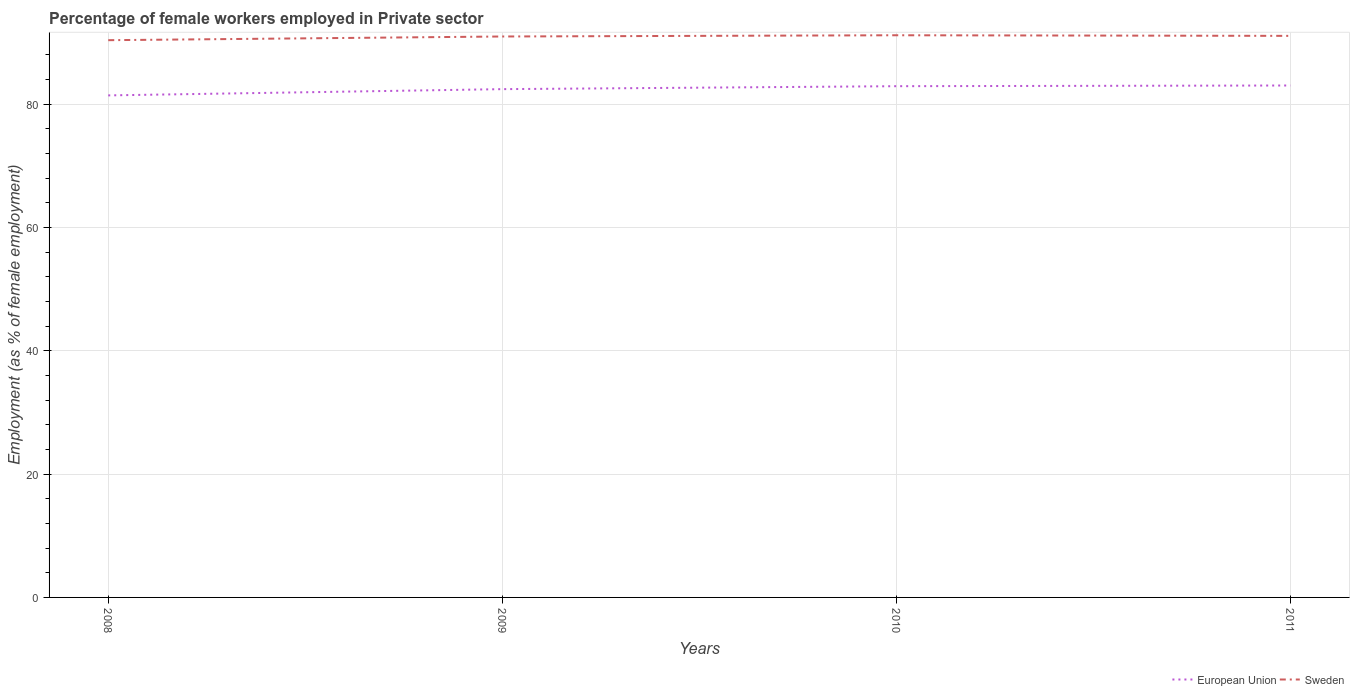How many different coloured lines are there?
Your response must be concise. 2. Does the line corresponding to Sweden intersect with the line corresponding to European Union?
Provide a succinct answer. No. Across all years, what is the maximum percentage of females employed in Private sector in Sweden?
Your response must be concise. 90.4. What is the total percentage of females employed in Private sector in Sweden in the graph?
Offer a very short reply. -0.6. What is the difference between the highest and the second highest percentage of females employed in Private sector in European Union?
Your answer should be very brief. 1.61. Is the percentage of females employed in Private sector in European Union strictly greater than the percentage of females employed in Private sector in Sweden over the years?
Provide a succinct answer. Yes. How many lines are there?
Make the answer very short. 2. How many years are there in the graph?
Provide a succinct answer. 4. Are the values on the major ticks of Y-axis written in scientific E-notation?
Provide a succinct answer. No. Does the graph contain grids?
Make the answer very short. Yes. What is the title of the graph?
Your answer should be very brief. Percentage of female workers employed in Private sector. Does "Belarus" appear as one of the legend labels in the graph?
Your answer should be very brief. No. What is the label or title of the X-axis?
Your answer should be compact. Years. What is the label or title of the Y-axis?
Provide a succinct answer. Employment (as % of female employment). What is the Employment (as % of female employment) of European Union in 2008?
Make the answer very short. 81.44. What is the Employment (as % of female employment) in Sweden in 2008?
Provide a short and direct response. 90.4. What is the Employment (as % of female employment) in European Union in 2009?
Keep it short and to the point. 82.46. What is the Employment (as % of female employment) of Sweden in 2009?
Your answer should be compact. 91. What is the Employment (as % of female employment) of European Union in 2010?
Offer a terse response. 82.94. What is the Employment (as % of female employment) in Sweden in 2010?
Make the answer very short. 91.2. What is the Employment (as % of female employment) in European Union in 2011?
Provide a short and direct response. 83.05. What is the Employment (as % of female employment) in Sweden in 2011?
Your answer should be compact. 91.1. Across all years, what is the maximum Employment (as % of female employment) of European Union?
Your answer should be very brief. 83.05. Across all years, what is the maximum Employment (as % of female employment) in Sweden?
Keep it short and to the point. 91.2. Across all years, what is the minimum Employment (as % of female employment) in European Union?
Provide a short and direct response. 81.44. Across all years, what is the minimum Employment (as % of female employment) in Sweden?
Your response must be concise. 90.4. What is the total Employment (as % of female employment) in European Union in the graph?
Ensure brevity in your answer.  329.89. What is the total Employment (as % of female employment) in Sweden in the graph?
Your answer should be very brief. 363.7. What is the difference between the Employment (as % of female employment) in European Union in 2008 and that in 2009?
Offer a very short reply. -1.01. What is the difference between the Employment (as % of female employment) in Sweden in 2008 and that in 2009?
Provide a short and direct response. -0.6. What is the difference between the Employment (as % of female employment) of European Union in 2008 and that in 2010?
Offer a terse response. -1.49. What is the difference between the Employment (as % of female employment) in Sweden in 2008 and that in 2010?
Provide a succinct answer. -0.8. What is the difference between the Employment (as % of female employment) of European Union in 2008 and that in 2011?
Ensure brevity in your answer.  -1.61. What is the difference between the Employment (as % of female employment) of Sweden in 2008 and that in 2011?
Give a very brief answer. -0.7. What is the difference between the Employment (as % of female employment) in European Union in 2009 and that in 2010?
Make the answer very short. -0.48. What is the difference between the Employment (as % of female employment) in Sweden in 2009 and that in 2010?
Offer a terse response. -0.2. What is the difference between the Employment (as % of female employment) in European Union in 2009 and that in 2011?
Ensure brevity in your answer.  -0.59. What is the difference between the Employment (as % of female employment) of European Union in 2010 and that in 2011?
Give a very brief answer. -0.11. What is the difference between the Employment (as % of female employment) in Sweden in 2010 and that in 2011?
Keep it short and to the point. 0.1. What is the difference between the Employment (as % of female employment) in European Union in 2008 and the Employment (as % of female employment) in Sweden in 2009?
Offer a very short reply. -9.56. What is the difference between the Employment (as % of female employment) of European Union in 2008 and the Employment (as % of female employment) of Sweden in 2010?
Give a very brief answer. -9.76. What is the difference between the Employment (as % of female employment) in European Union in 2008 and the Employment (as % of female employment) in Sweden in 2011?
Provide a succinct answer. -9.66. What is the difference between the Employment (as % of female employment) in European Union in 2009 and the Employment (as % of female employment) in Sweden in 2010?
Your answer should be compact. -8.74. What is the difference between the Employment (as % of female employment) of European Union in 2009 and the Employment (as % of female employment) of Sweden in 2011?
Provide a succinct answer. -8.64. What is the difference between the Employment (as % of female employment) in European Union in 2010 and the Employment (as % of female employment) in Sweden in 2011?
Provide a short and direct response. -8.16. What is the average Employment (as % of female employment) in European Union per year?
Ensure brevity in your answer.  82.47. What is the average Employment (as % of female employment) in Sweden per year?
Offer a very short reply. 90.92. In the year 2008, what is the difference between the Employment (as % of female employment) in European Union and Employment (as % of female employment) in Sweden?
Your answer should be compact. -8.96. In the year 2009, what is the difference between the Employment (as % of female employment) in European Union and Employment (as % of female employment) in Sweden?
Provide a short and direct response. -8.54. In the year 2010, what is the difference between the Employment (as % of female employment) in European Union and Employment (as % of female employment) in Sweden?
Provide a short and direct response. -8.26. In the year 2011, what is the difference between the Employment (as % of female employment) in European Union and Employment (as % of female employment) in Sweden?
Give a very brief answer. -8.05. What is the ratio of the Employment (as % of female employment) in Sweden in 2008 to that in 2010?
Ensure brevity in your answer.  0.99. What is the ratio of the Employment (as % of female employment) in European Union in 2008 to that in 2011?
Ensure brevity in your answer.  0.98. What is the ratio of the Employment (as % of female employment) of European Union in 2009 to that in 2010?
Ensure brevity in your answer.  0.99. What is the ratio of the Employment (as % of female employment) in Sweden in 2009 to that in 2010?
Your answer should be compact. 1. What is the ratio of the Employment (as % of female employment) in European Union in 2009 to that in 2011?
Offer a very short reply. 0.99. What is the ratio of the Employment (as % of female employment) in European Union in 2010 to that in 2011?
Offer a terse response. 1. What is the difference between the highest and the second highest Employment (as % of female employment) of European Union?
Your answer should be compact. 0.11. What is the difference between the highest and the lowest Employment (as % of female employment) of European Union?
Your answer should be very brief. 1.61. 